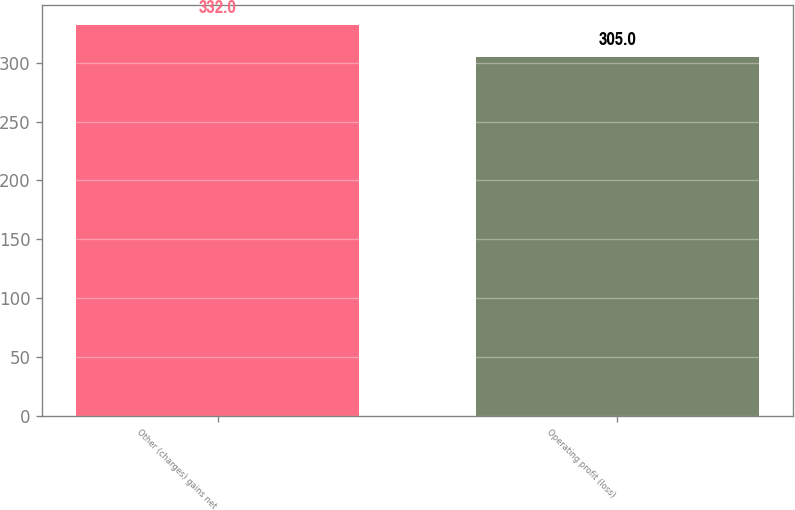Convert chart. <chart><loc_0><loc_0><loc_500><loc_500><bar_chart><fcel>Other (charges) gains net<fcel>Operating profit (loss)<nl><fcel>332<fcel>305<nl></chart> 